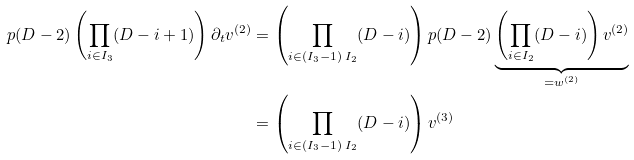Convert formula to latex. <formula><loc_0><loc_0><loc_500><loc_500>p ( D - 2 ) \left ( \prod _ { i \in I _ { 3 } } ( D - i + 1 ) \right ) \partial _ { t } v ^ { ( 2 ) } & = \left ( \prod _ { i \in ( I _ { 3 } - 1 ) \ I _ { 2 } } ( D - i ) \right ) p ( D - 2 ) \underbrace { \left ( \prod _ { i \in I _ { 2 } } ( D - i ) \right ) v ^ { ( 2 ) } } _ { = w ^ { ( 2 ) } } \\ & = \left ( \prod _ { i \in ( I _ { 3 } - 1 ) \ I _ { 2 } } ( D - i ) \right ) v ^ { ( 3 ) }</formula> 